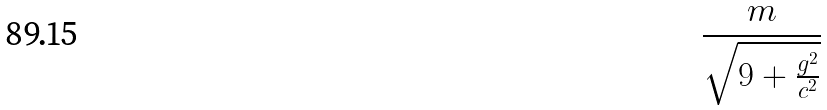<formula> <loc_0><loc_0><loc_500><loc_500>\frac { m } { \sqrt { 9 + \frac { g ^ { 2 } } { c ^ { 2 } } } }</formula> 